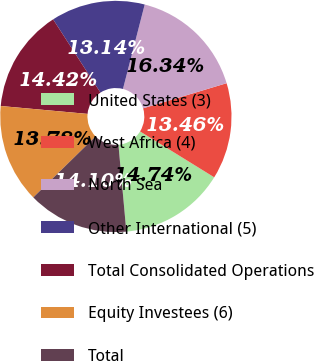Convert chart. <chart><loc_0><loc_0><loc_500><loc_500><pie_chart><fcel>United States (3)<fcel>West Africa (4)<fcel>North Sea<fcel>Other International (5)<fcel>Total Consolidated Operations<fcel>Equity Investees (6)<fcel>Total<nl><fcel>14.74%<fcel>13.46%<fcel>16.34%<fcel>13.14%<fcel>14.42%<fcel>13.78%<fcel>14.1%<nl></chart> 